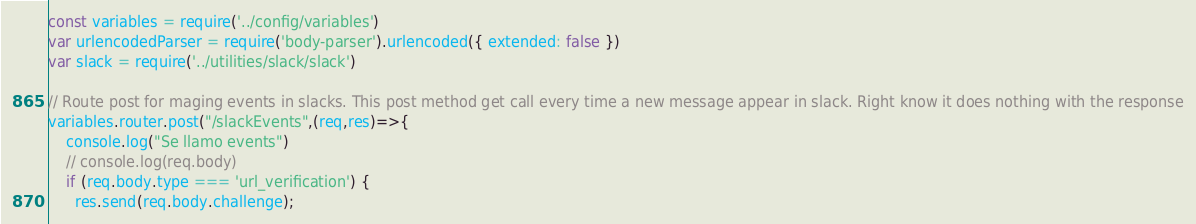Convert code to text. <code><loc_0><loc_0><loc_500><loc_500><_JavaScript_>const variables = require('../config/variables')
var urlencodedParser = require('body-parser').urlencoded({ extended: false })
var slack = require('../utilities/slack/slack')

// Route post for maging events in slacks. This post method get call every time a new message appear in slack. Right know it does nothing with the response
variables.router.post("/slackEvents",(req,res)=>{
    console.log("Se llamo events")
    // console.log(req.body)
    if (req.body.type === 'url_verification') {
      res.send(req.body.challenge);</code> 